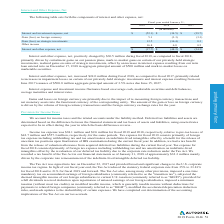Looking at Autodesk's financial data, please calculate: What was the percentage increase in gross profit from 2018 to 2019? To answer this question, I need to perform calculations using the financial data. The calculation is: (2,283.9-1,753.2)/1,753.2, which equals 30.27 (percentage). The key data points involved are: 1,753.2, 2,283.9. Also, can you calculate: What is the total sales in 2017? Based on the calculation: 1,689.1/83% , the result is 2035.06 (in millions). The key data points involved are: 1,689.1, 83. Also, How does the company use non-GAAP measures? Based on the financial document, the answer is For our internal budgeting and resource allocation process and as a means to provide consistency in period-to-period comparisons, we use non-GAAP measures to supplement our consolidated financial statements presented on a GAAP basis. These non-GAAP measures do not include certain items that may have a material impact upon our reported financial results. We also use non-GAAP measures in making operating decisions because we believe those measures provide meaningful supplemental information regarding our earning potential and performance for management by excluding certain benefits, credits, expenses and charges that may not be indicative of our core business operating results.. Also, Why are these non-GAAP measures useful for investors? Based on the financial document, the answer is This allows investors and others to better understand and evaluate our operating results and future prospects in the same manner as management, compare financial results across accounting periods and to those of peer companies and to better understand the long-term performance of our core business. Also, can you calculate: How much did gross margin change from fiscal year ending January 31, 2019 compared to the prior year? Based on the calculation: 89%-85% , the result is 4 (percentage). The key data points involved are: 85, 89. Also, What is the net loss in 2018? Based on the financial document, the answer is $(566.9). 